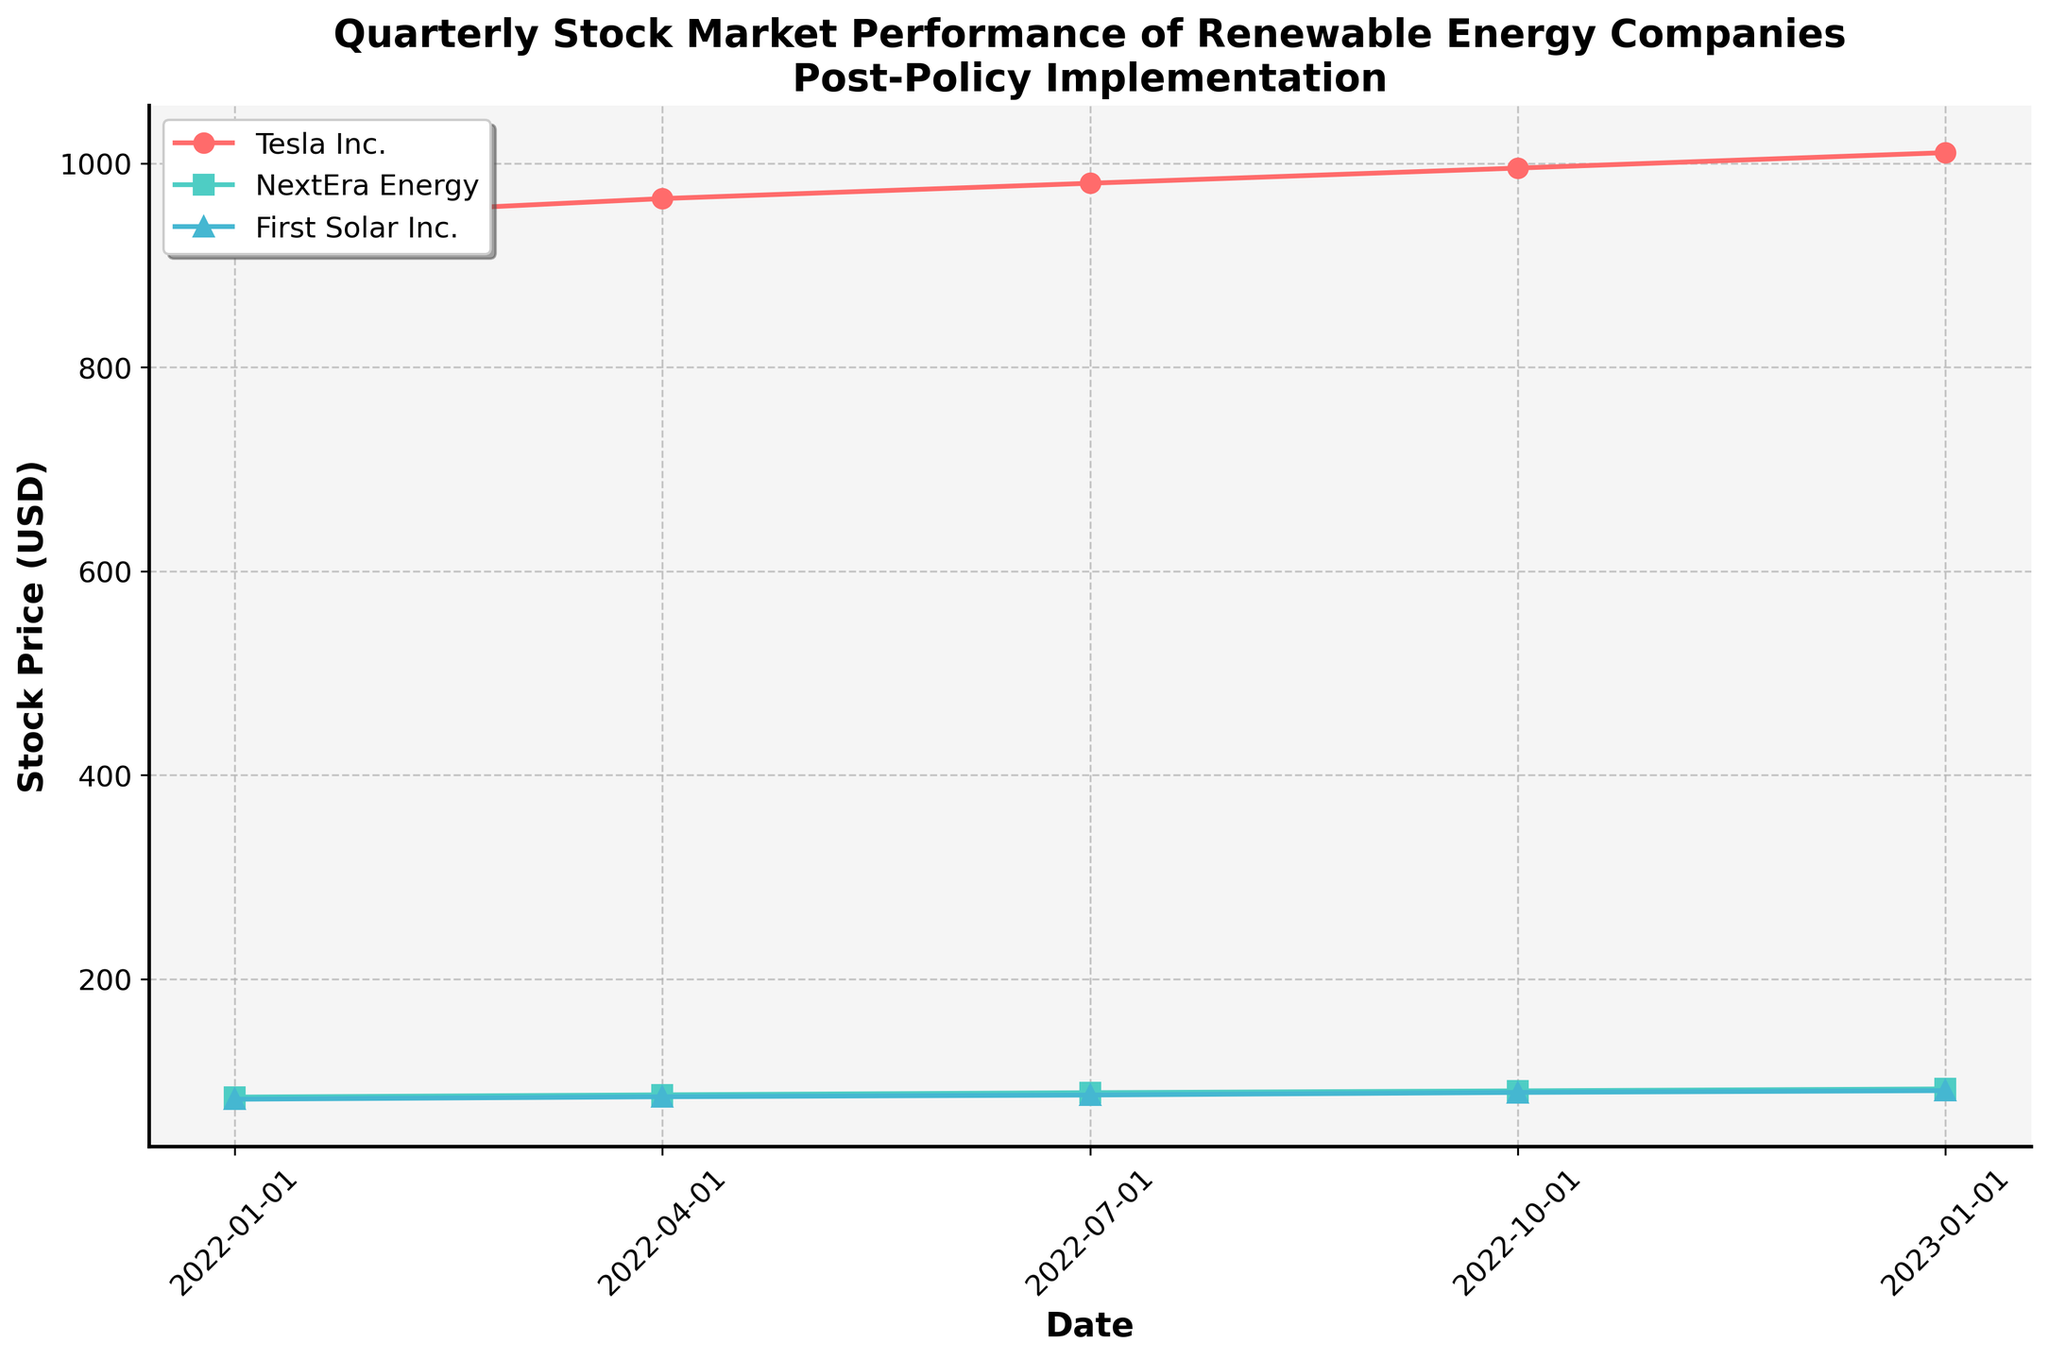what is the title of the plot? The title is located at the top of the plot and is usually written in a larger and bold font to distinguish it from other text elements. The plot's title is "Quarterly Stock Market Performance of Renewable Energy Companies Post-Policy Implementation".
Answer: Quarterly Stock Market Performance of Renewable Energy Companies Post-Policy Implementation What are the tick intervals on the x-axis? By observing the x-axis, we can see that the dates are plotted at quarterly intervals, specifically: 2022-01-01, 2022-04-01, 2022-07-01, 2022-10-01, and 2023-01-01.
Answer: Quarterly Which company has the highest closing stock price in the last quarter shown? To find this, observe the data points on the plot corresponding to the last quarter (2023-01-01). Compare the closing stock prices for Tesla Inc., NextEra Energy, and First Solar Inc. Tesla Inc. has the highest closing stock price.
Answer: Tesla Inc What is the general trend of Tesla Inc.'s stock prices over the period shown? To determine the trend, look at Tesla Inc.'s closing stock prices over time: 945.32 (2022-01-01), 965.40 (2022-04-01), 980.45 (2022-07-01), 995.32 (2022-10-01), and 1010.45 (2023-01-01). All values show an upward trend.
Answer: Upward On the initial date shown, which company had the lowest closing stock price, and what was it? Look at the closing stock prices for all companies on 2022-01-01: Tesla Inc. (945.32), NextEra Energy (84.23), First Solar Inc. (82.12). The lowest closing stock price was First Solar Inc. with 82.12.
Answer: First Solar Inc., 82.12 What is the average closing stock price for NextEra Energy across all quarters shown? Add the closing prices for NextEra Energy: 84.23 (Q1), 86.45 (Q2), 88.56 (Q3), 90.34 (Q4), 92.23 (Q5). Sum: 84.23 + 86.45 + 88.56 + 90.34 + 92.23 = 441.81. Then, divide by the number of quarters (5). Average: 441.81 / 5 = 88.362
Answer: 88.362 